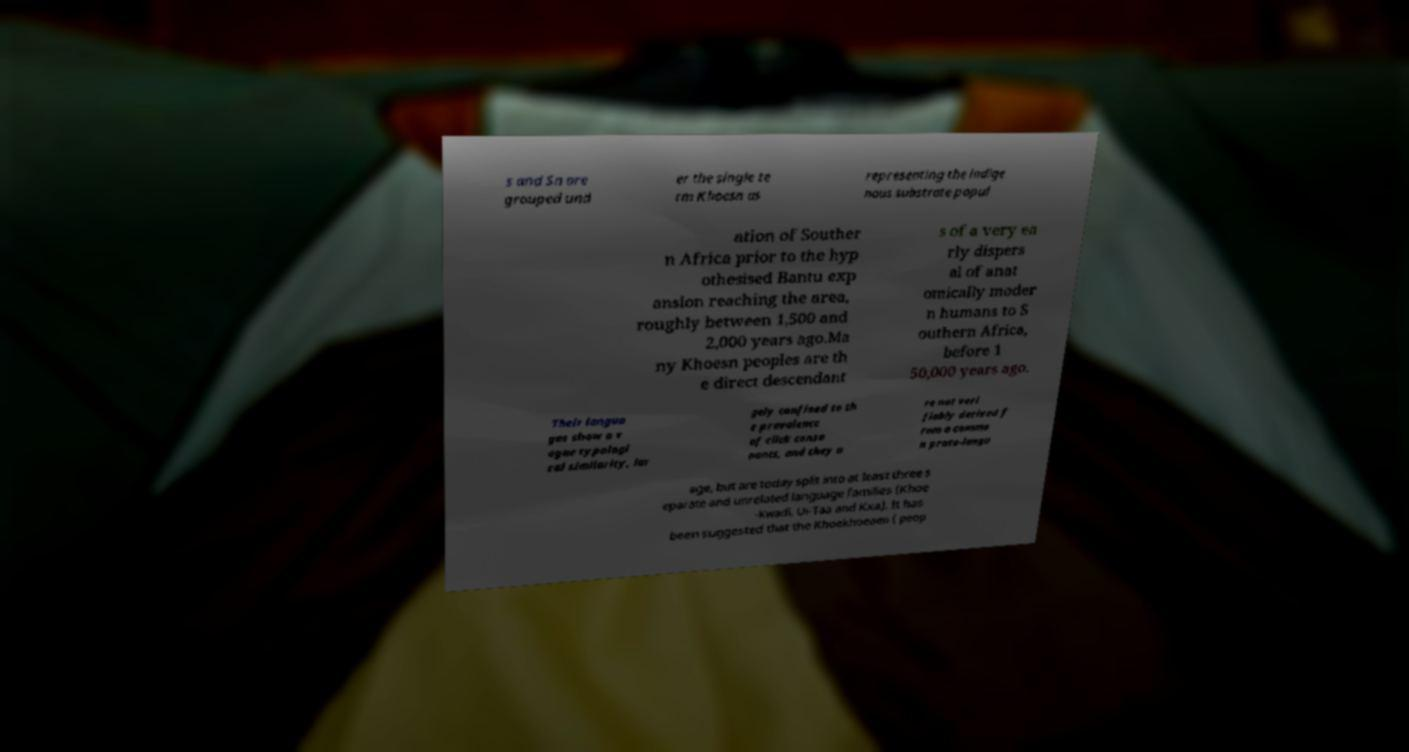Can you read and provide the text displayed in the image?This photo seems to have some interesting text. Can you extract and type it out for me? s and Sn are grouped und er the single te rm Khoesn as representing the indige nous substrate popul ation of Souther n Africa prior to the hyp othesised Bantu exp ansion reaching the area, roughly between 1,500 and 2,000 years ago.Ma ny Khoesn peoples are th e direct descendant s of a very ea rly dispers al of anat omically moder n humans to S outhern Africa, before 1 50,000 years ago. Their langua ges show a v ague typologi cal similarity, lar gely confined to th e prevalence of click conso nants, and they a re not veri fiably derived f rom a commo n proto-langu age, but are today split into at least three s eparate and unrelated language families (Khoe -Kwadi, Ui-Taa and Kxa). It has been suggested that the Khoekhoeaen ( peop 